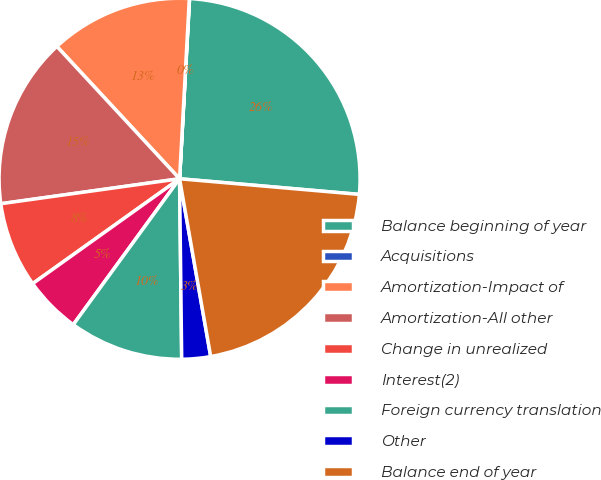Convert chart to OTSL. <chart><loc_0><loc_0><loc_500><loc_500><pie_chart><fcel>Balance beginning of year<fcel>Acquisitions<fcel>Amortization-Impact of<fcel>Amortization-All other<fcel>Change in unrealized<fcel>Interest(2)<fcel>Foreign currency translation<fcel>Other<fcel>Balance end of year<nl><fcel>25.5%<fcel>0.02%<fcel>12.76%<fcel>15.31%<fcel>7.66%<fcel>5.11%<fcel>10.21%<fcel>2.57%<fcel>20.86%<nl></chart> 